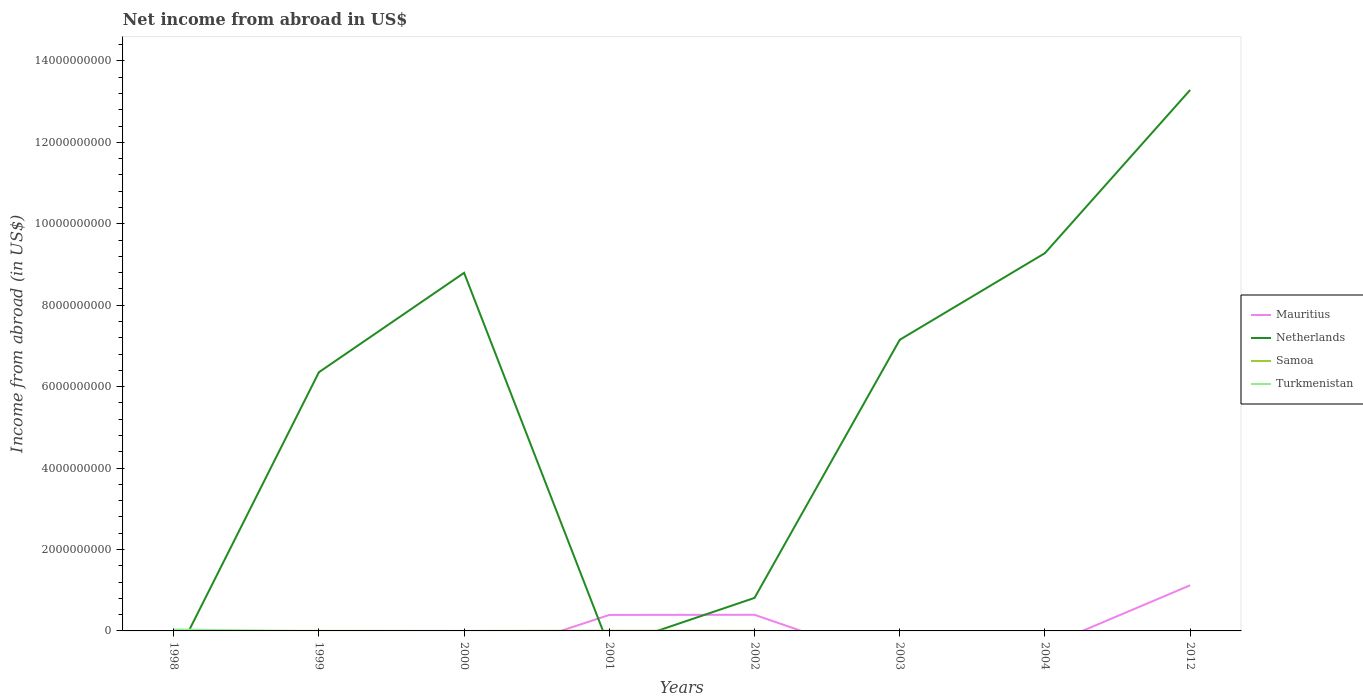How many different coloured lines are there?
Offer a very short reply. 4. Does the line corresponding to Netherlands intersect with the line corresponding to Samoa?
Your response must be concise. Yes. What is the total net income from abroad in Netherlands in the graph?
Keep it short and to the point. -1.25e+1. What is the difference between the highest and the second highest net income from abroad in Turkmenistan?
Give a very brief answer. 3.51e+07. What is the difference between the highest and the lowest net income from abroad in Samoa?
Provide a short and direct response. 4. How many lines are there?
Provide a short and direct response. 4. How many years are there in the graph?
Give a very brief answer. 8. Are the values on the major ticks of Y-axis written in scientific E-notation?
Provide a short and direct response. No. Does the graph contain any zero values?
Provide a succinct answer. Yes. How are the legend labels stacked?
Your answer should be very brief. Vertical. What is the title of the graph?
Your response must be concise. Net income from abroad in US$. Does "Greenland" appear as one of the legend labels in the graph?
Your answer should be very brief. No. What is the label or title of the X-axis?
Ensure brevity in your answer.  Years. What is the label or title of the Y-axis?
Keep it short and to the point. Income from abroad (in US$). What is the Income from abroad (in US$) in Samoa in 1998?
Offer a very short reply. 2.85e+06. What is the Income from abroad (in US$) in Turkmenistan in 1998?
Provide a short and direct response. 3.51e+07. What is the Income from abroad (in US$) in Netherlands in 1999?
Your answer should be very brief. 6.35e+09. What is the Income from abroad (in US$) in Samoa in 1999?
Give a very brief answer. 1.67e+06. What is the Income from abroad (in US$) of Netherlands in 2000?
Your response must be concise. 8.79e+09. What is the Income from abroad (in US$) of Samoa in 2000?
Your response must be concise. 6.00e+04. What is the Income from abroad (in US$) of Mauritius in 2001?
Make the answer very short. 3.93e+08. What is the Income from abroad (in US$) in Netherlands in 2001?
Your response must be concise. 0. What is the Income from abroad (in US$) in Samoa in 2001?
Provide a succinct answer. 4.73e+06. What is the Income from abroad (in US$) of Turkmenistan in 2001?
Provide a succinct answer. 0. What is the Income from abroad (in US$) in Mauritius in 2002?
Offer a terse response. 3.96e+08. What is the Income from abroad (in US$) in Netherlands in 2002?
Provide a short and direct response. 8.11e+08. What is the Income from abroad (in US$) of Samoa in 2002?
Make the answer very short. 2.39e+06. What is the Income from abroad (in US$) in Netherlands in 2003?
Provide a succinct answer. 7.15e+09. What is the Income from abroad (in US$) in Mauritius in 2004?
Offer a very short reply. 0. What is the Income from abroad (in US$) of Netherlands in 2004?
Provide a succinct answer. 9.28e+09. What is the Income from abroad (in US$) in Mauritius in 2012?
Keep it short and to the point. 1.12e+09. What is the Income from abroad (in US$) in Netherlands in 2012?
Give a very brief answer. 1.33e+1. What is the Income from abroad (in US$) in Samoa in 2012?
Your answer should be compact. 0. What is the Income from abroad (in US$) of Turkmenistan in 2012?
Ensure brevity in your answer.  0. Across all years, what is the maximum Income from abroad (in US$) in Mauritius?
Keep it short and to the point. 1.12e+09. Across all years, what is the maximum Income from abroad (in US$) of Netherlands?
Your answer should be compact. 1.33e+1. Across all years, what is the maximum Income from abroad (in US$) in Samoa?
Your answer should be very brief. 4.73e+06. Across all years, what is the maximum Income from abroad (in US$) in Turkmenistan?
Offer a very short reply. 3.51e+07. Across all years, what is the minimum Income from abroad (in US$) of Mauritius?
Provide a succinct answer. 0. Across all years, what is the minimum Income from abroad (in US$) of Samoa?
Your answer should be compact. 0. Across all years, what is the minimum Income from abroad (in US$) of Turkmenistan?
Provide a succinct answer. 0. What is the total Income from abroad (in US$) of Mauritius in the graph?
Ensure brevity in your answer.  1.91e+09. What is the total Income from abroad (in US$) of Netherlands in the graph?
Your answer should be very brief. 4.57e+1. What is the total Income from abroad (in US$) of Samoa in the graph?
Your answer should be compact. 1.17e+07. What is the total Income from abroad (in US$) in Turkmenistan in the graph?
Ensure brevity in your answer.  3.51e+07. What is the difference between the Income from abroad (in US$) of Samoa in 1998 and that in 1999?
Give a very brief answer. 1.18e+06. What is the difference between the Income from abroad (in US$) in Samoa in 1998 and that in 2000?
Provide a succinct answer. 2.79e+06. What is the difference between the Income from abroad (in US$) in Samoa in 1998 and that in 2001?
Ensure brevity in your answer.  -1.88e+06. What is the difference between the Income from abroad (in US$) of Samoa in 1998 and that in 2002?
Offer a terse response. 4.63e+05. What is the difference between the Income from abroad (in US$) in Netherlands in 1999 and that in 2000?
Give a very brief answer. -2.44e+09. What is the difference between the Income from abroad (in US$) in Samoa in 1999 and that in 2000?
Give a very brief answer. 1.61e+06. What is the difference between the Income from abroad (in US$) in Samoa in 1999 and that in 2001?
Offer a terse response. -3.06e+06. What is the difference between the Income from abroad (in US$) of Netherlands in 1999 and that in 2002?
Keep it short and to the point. 5.54e+09. What is the difference between the Income from abroad (in US$) of Samoa in 1999 and that in 2002?
Make the answer very short. -7.20e+05. What is the difference between the Income from abroad (in US$) in Netherlands in 1999 and that in 2003?
Ensure brevity in your answer.  -7.97e+08. What is the difference between the Income from abroad (in US$) in Netherlands in 1999 and that in 2004?
Give a very brief answer. -2.92e+09. What is the difference between the Income from abroad (in US$) in Netherlands in 1999 and that in 2012?
Keep it short and to the point. -6.93e+09. What is the difference between the Income from abroad (in US$) of Samoa in 2000 and that in 2001?
Give a very brief answer. -4.67e+06. What is the difference between the Income from abroad (in US$) of Netherlands in 2000 and that in 2002?
Offer a terse response. 7.98e+09. What is the difference between the Income from abroad (in US$) in Samoa in 2000 and that in 2002?
Keep it short and to the point. -2.33e+06. What is the difference between the Income from abroad (in US$) in Netherlands in 2000 and that in 2003?
Your response must be concise. 1.64e+09. What is the difference between the Income from abroad (in US$) of Netherlands in 2000 and that in 2004?
Ensure brevity in your answer.  -4.84e+08. What is the difference between the Income from abroad (in US$) of Netherlands in 2000 and that in 2012?
Keep it short and to the point. -4.49e+09. What is the difference between the Income from abroad (in US$) in Samoa in 2001 and that in 2002?
Keep it short and to the point. 2.34e+06. What is the difference between the Income from abroad (in US$) of Mauritius in 2001 and that in 2012?
Provide a short and direct response. -7.28e+08. What is the difference between the Income from abroad (in US$) in Netherlands in 2002 and that in 2003?
Provide a succinct answer. -6.34e+09. What is the difference between the Income from abroad (in US$) of Netherlands in 2002 and that in 2004?
Offer a very short reply. -8.47e+09. What is the difference between the Income from abroad (in US$) in Mauritius in 2002 and that in 2012?
Provide a succinct answer. -7.25e+08. What is the difference between the Income from abroad (in US$) in Netherlands in 2002 and that in 2012?
Your answer should be compact. -1.25e+1. What is the difference between the Income from abroad (in US$) of Netherlands in 2003 and that in 2004?
Provide a succinct answer. -2.13e+09. What is the difference between the Income from abroad (in US$) of Netherlands in 2003 and that in 2012?
Make the answer very short. -6.14e+09. What is the difference between the Income from abroad (in US$) in Netherlands in 2004 and that in 2012?
Make the answer very short. -4.01e+09. What is the difference between the Income from abroad (in US$) in Netherlands in 1999 and the Income from abroad (in US$) in Samoa in 2000?
Make the answer very short. 6.35e+09. What is the difference between the Income from abroad (in US$) of Netherlands in 1999 and the Income from abroad (in US$) of Samoa in 2001?
Make the answer very short. 6.35e+09. What is the difference between the Income from abroad (in US$) of Netherlands in 1999 and the Income from abroad (in US$) of Samoa in 2002?
Keep it short and to the point. 6.35e+09. What is the difference between the Income from abroad (in US$) in Netherlands in 2000 and the Income from abroad (in US$) in Samoa in 2001?
Your answer should be very brief. 8.79e+09. What is the difference between the Income from abroad (in US$) of Netherlands in 2000 and the Income from abroad (in US$) of Samoa in 2002?
Your answer should be compact. 8.79e+09. What is the difference between the Income from abroad (in US$) of Mauritius in 2001 and the Income from abroad (in US$) of Netherlands in 2002?
Keep it short and to the point. -4.18e+08. What is the difference between the Income from abroad (in US$) of Mauritius in 2001 and the Income from abroad (in US$) of Samoa in 2002?
Offer a very short reply. 3.91e+08. What is the difference between the Income from abroad (in US$) in Mauritius in 2001 and the Income from abroad (in US$) in Netherlands in 2003?
Ensure brevity in your answer.  -6.76e+09. What is the difference between the Income from abroad (in US$) of Mauritius in 2001 and the Income from abroad (in US$) of Netherlands in 2004?
Make the answer very short. -8.88e+09. What is the difference between the Income from abroad (in US$) in Mauritius in 2001 and the Income from abroad (in US$) in Netherlands in 2012?
Ensure brevity in your answer.  -1.29e+1. What is the difference between the Income from abroad (in US$) of Mauritius in 2002 and the Income from abroad (in US$) of Netherlands in 2003?
Your response must be concise. -6.75e+09. What is the difference between the Income from abroad (in US$) in Mauritius in 2002 and the Income from abroad (in US$) in Netherlands in 2004?
Make the answer very short. -8.88e+09. What is the difference between the Income from abroad (in US$) of Mauritius in 2002 and the Income from abroad (in US$) of Netherlands in 2012?
Ensure brevity in your answer.  -1.29e+1. What is the average Income from abroad (in US$) of Mauritius per year?
Offer a terse response. 2.39e+08. What is the average Income from abroad (in US$) of Netherlands per year?
Your answer should be very brief. 5.71e+09. What is the average Income from abroad (in US$) of Samoa per year?
Keep it short and to the point. 1.46e+06. What is the average Income from abroad (in US$) of Turkmenistan per year?
Offer a terse response. 4.38e+06. In the year 1998, what is the difference between the Income from abroad (in US$) of Samoa and Income from abroad (in US$) of Turkmenistan?
Keep it short and to the point. -3.22e+07. In the year 1999, what is the difference between the Income from abroad (in US$) in Netherlands and Income from abroad (in US$) in Samoa?
Provide a short and direct response. 6.35e+09. In the year 2000, what is the difference between the Income from abroad (in US$) of Netherlands and Income from abroad (in US$) of Samoa?
Your answer should be very brief. 8.79e+09. In the year 2001, what is the difference between the Income from abroad (in US$) in Mauritius and Income from abroad (in US$) in Samoa?
Keep it short and to the point. 3.88e+08. In the year 2002, what is the difference between the Income from abroad (in US$) of Mauritius and Income from abroad (in US$) of Netherlands?
Offer a very short reply. -4.15e+08. In the year 2002, what is the difference between the Income from abroad (in US$) in Mauritius and Income from abroad (in US$) in Samoa?
Offer a terse response. 3.94e+08. In the year 2002, what is the difference between the Income from abroad (in US$) of Netherlands and Income from abroad (in US$) of Samoa?
Your answer should be very brief. 8.09e+08. In the year 2012, what is the difference between the Income from abroad (in US$) in Mauritius and Income from abroad (in US$) in Netherlands?
Your answer should be compact. -1.22e+1. What is the ratio of the Income from abroad (in US$) in Samoa in 1998 to that in 1999?
Your answer should be compact. 1.71. What is the ratio of the Income from abroad (in US$) of Samoa in 1998 to that in 2000?
Offer a very short reply. 47.55. What is the ratio of the Income from abroad (in US$) of Samoa in 1998 to that in 2001?
Your response must be concise. 0.6. What is the ratio of the Income from abroad (in US$) in Samoa in 1998 to that in 2002?
Provide a succinct answer. 1.19. What is the ratio of the Income from abroad (in US$) in Netherlands in 1999 to that in 2000?
Provide a short and direct response. 0.72. What is the ratio of the Income from abroad (in US$) of Samoa in 1999 to that in 2000?
Offer a very short reply. 27.83. What is the ratio of the Income from abroad (in US$) in Samoa in 1999 to that in 2001?
Provide a short and direct response. 0.35. What is the ratio of the Income from abroad (in US$) in Netherlands in 1999 to that in 2002?
Keep it short and to the point. 7.83. What is the ratio of the Income from abroad (in US$) of Samoa in 1999 to that in 2002?
Make the answer very short. 0.7. What is the ratio of the Income from abroad (in US$) of Netherlands in 1999 to that in 2003?
Provide a succinct answer. 0.89. What is the ratio of the Income from abroad (in US$) in Netherlands in 1999 to that in 2004?
Provide a short and direct response. 0.68. What is the ratio of the Income from abroad (in US$) of Netherlands in 1999 to that in 2012?
Your answer should be very brief. 0.48. What is the ratio of the Income from abroad (in US$) of Samoa in 2000 to that in 2001?
Provide a succinct answer. 0.01. What is the ratio of the Income from abroad (in US$) of Netherlands in 2000 to that in 2002?
Make the answer very short. 10.84. What is the ratio of the Income from abroad (in US$) of Samoa in 2000 to that in 2002?
Your response must be concise. 0.03. What is the ratio of the Income from abroad (in US$) of Netherlands in 2000 to that in 2003?
Give a very brief answer. 1.23. What is the ratio of the Income from abroad (in US$) in Netherlands in 2000 to that in 2004?
Keep it short and to the point. 0.95. What is the ratio of the Income from abroad (in US$) in Netherlands in 2000 to that in 2012?
Your answer should be compact. 0.66. What is the ratio of the Income from abroad (in US$) in Samoa in 2001 to that in 2002?
Make the answer very short. 1.98. What is the ratio of the Income from abroad (in US$) of Mauritius in 2001 to that in 2012?
Ensure brevity in your answer.  0.35. What is the ratio of the Income from abroad (in US$) of Netherlands in 2002 to that in 2003?
Your answer should be very brief. 0.11. What is the ratio of the Income from abroad (in US$) in Netherlands in 2002 to that in 2004?
Provide a short and direct response. 0.09. What is the ratio of the Income from abroad (in US$) of Mauritius in 2002 to that in 2012?
Provide a short and direct response. 0.35. What is the ratio of the Income from abroad (in US$) of Netherlands in 2002 to that in 2012?
Your answer should be compact. 0.06. What is the ratio of the Income from abroad (in US$) of Netherlands in 2003 to that in 2004?
Provide a succinct answer. 0.77. What is the ratio of the Income from abroad (in US$) in Netherlands in 2003 to that in 2012?
Your answer should be compact. 0.54. What is the ratio of the Income from abroad (in US$) in Netherlands in 2004 to that in 2012?
Keep it short and to the point. 0.7. What is the difference between the highest and the second highest Income from abroad (in US$) in Mauritius?
Your answer should be very brief. 7.25e+08. What is the difference between the highest and the second highest Income from abroad (in US$) of Netherlands?
Your answer should be very brief. 4.01e+09. What is the difference between the highest and the second highest Income from abroad (in US$) of Samoa?
Offer a terse response. 1.88e+06. What is the difference between the highest and the lowest Income from abroad (in US$) in Mauritius?
Your answer should be compact. 1.12e+09. What is the difference between the highest and the lowest Income from abroad (in US$) in Netherlands?
Offer a very short reply. 1.33e+1. What is the difference between the highest and the lowest Income from abroad (in US$) in Samoa?
Keep it short and to the point. 4.73e+06. What is the difference between the highest and the lowest Income from abroad (in US$) of Turkmenistan?
Keep it short and to the point. 3.51e+07. 